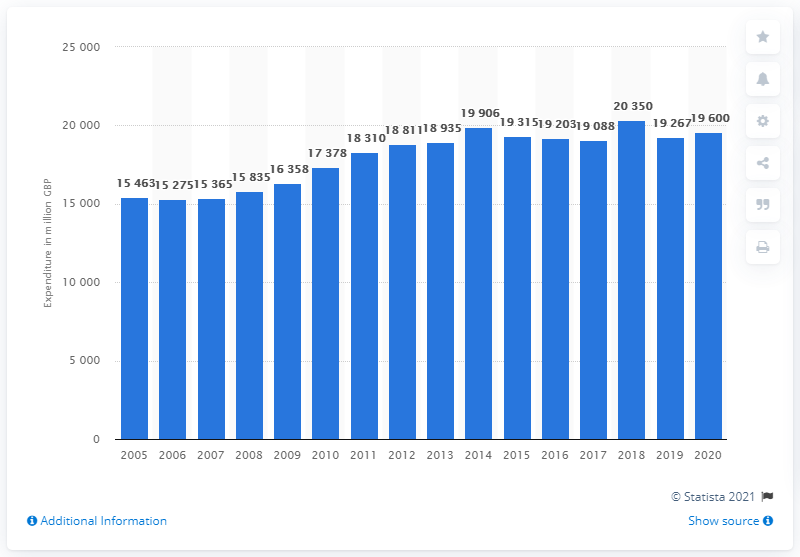Identify some key points in this picture. In 2020, the total amount of money spent by consumers in the UK on tobacco was approximately 19,600. 